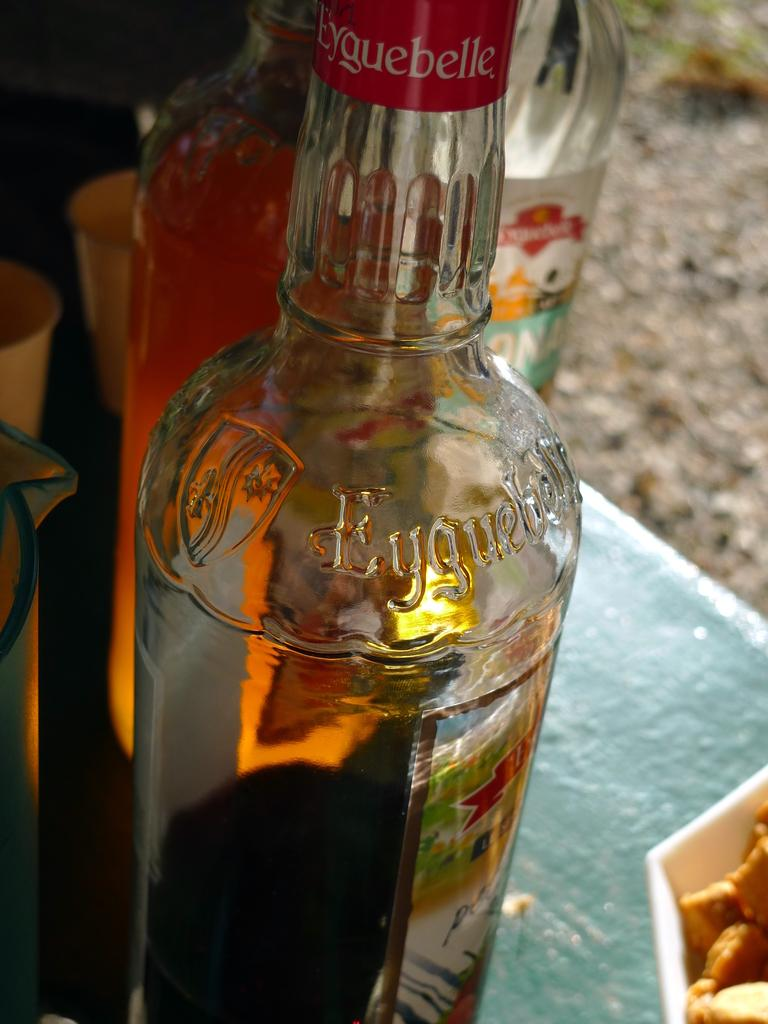What is present on the table in the image? There is a bottle and a glass on the table in the image. Can you describe the objects on the table? The objects on the table are a bottle and a glass. How many cubs are sitting on the chairs in the image? There are no chairs or cubs present in the image. What type of approval is required for the objects in the image? There is no approval process mentioned or implied in the image, as it only features a bottle and a glass on a table. 